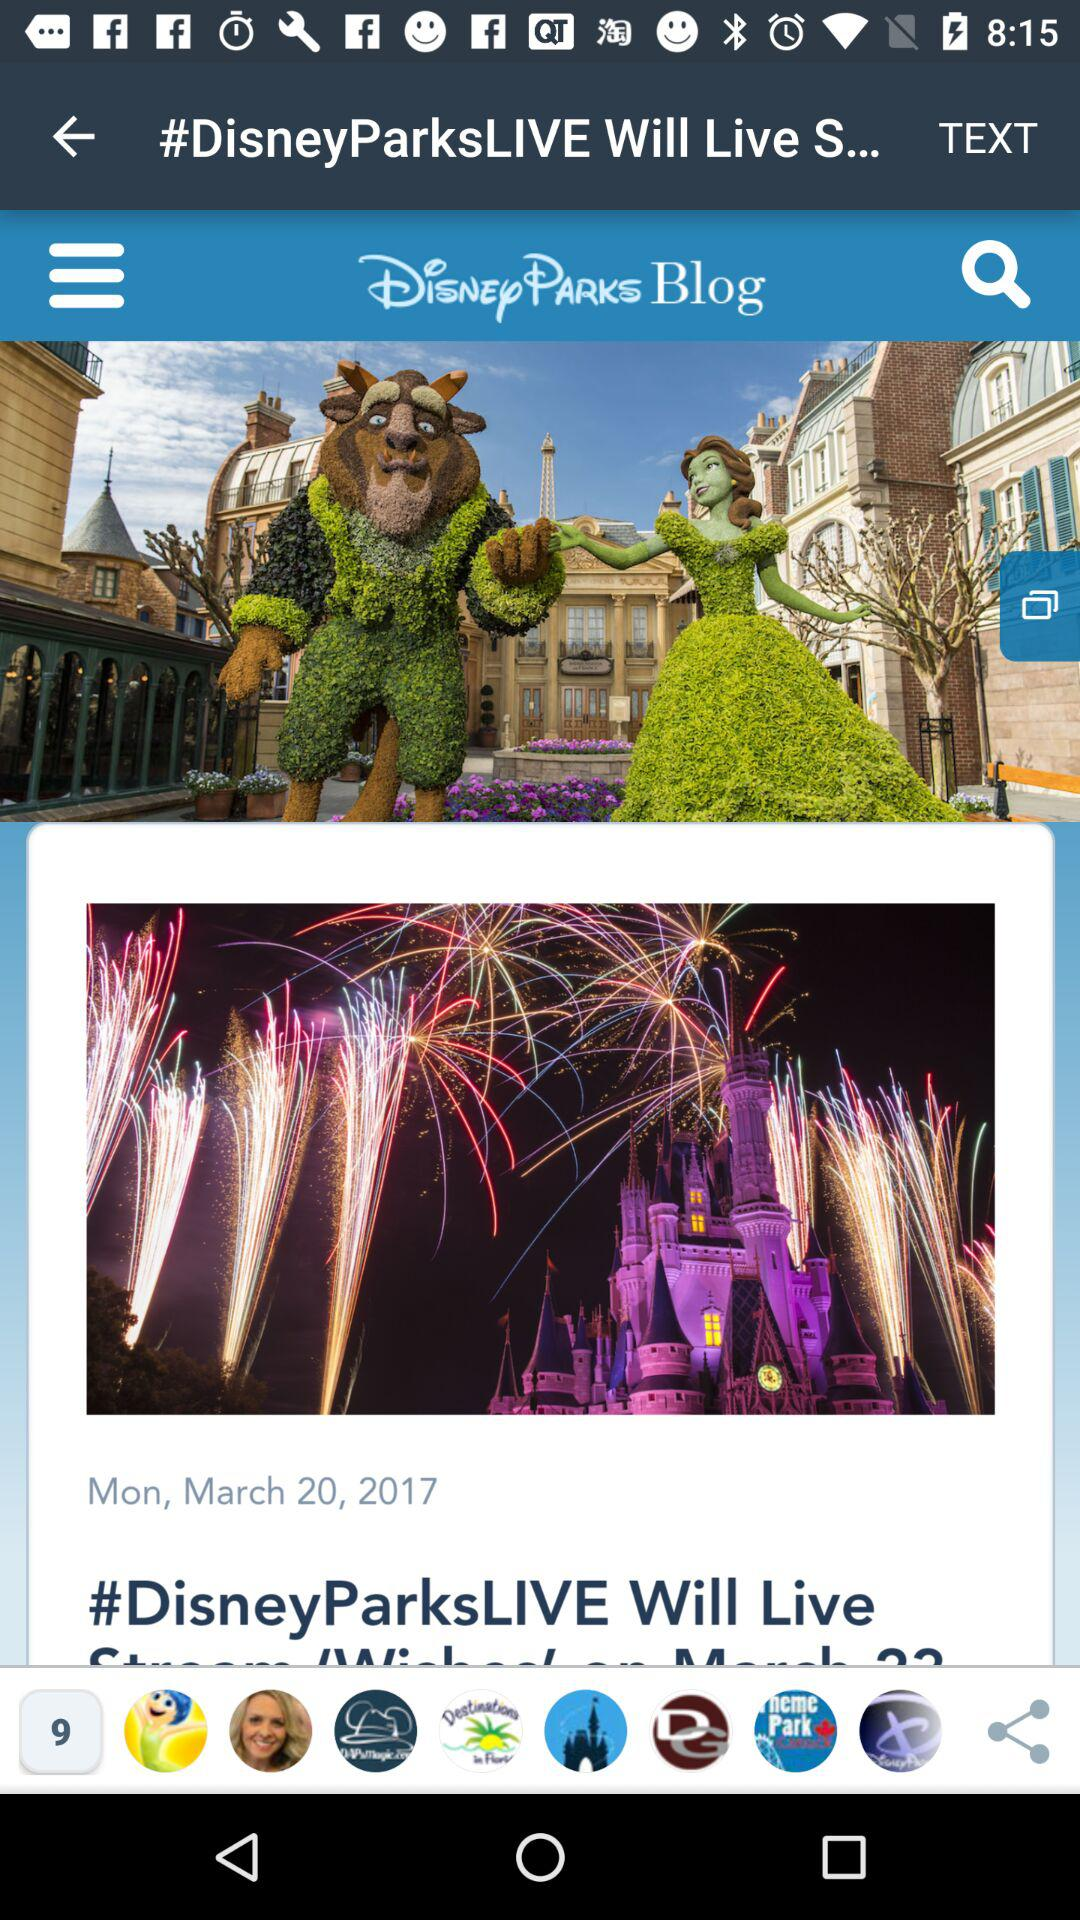What day is it on the given date? The day is Monday. 